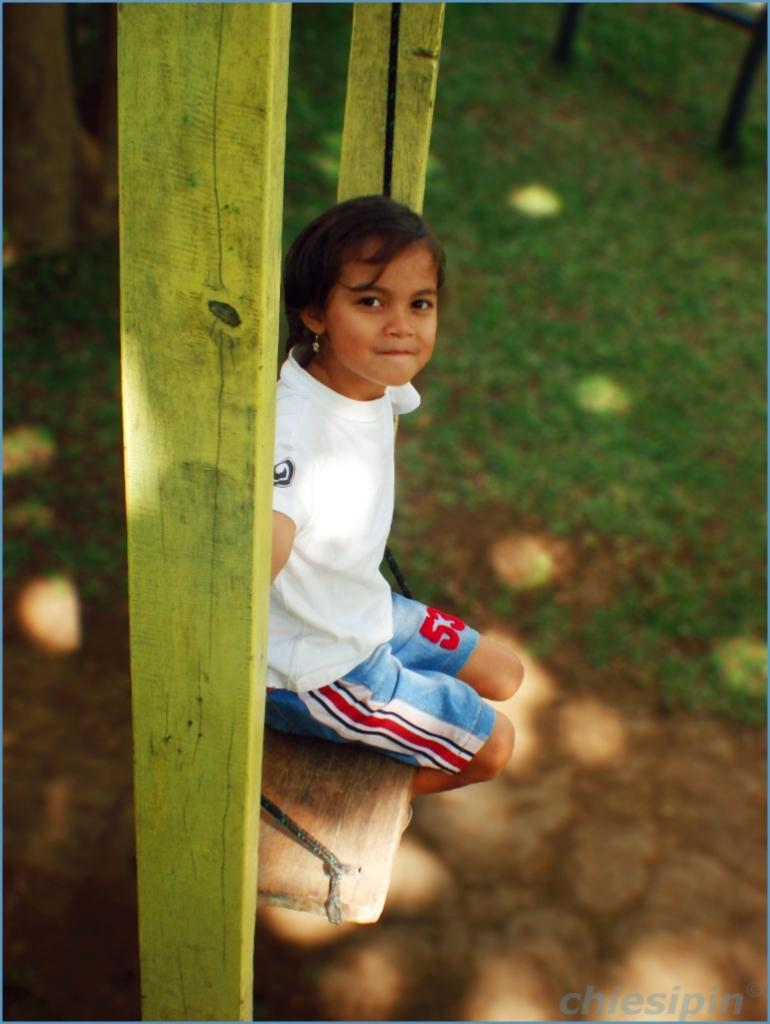<image>
Relay a brief, clear account of the picture shown. The number 53 is printed on blue shorts being worn by a little girl. 